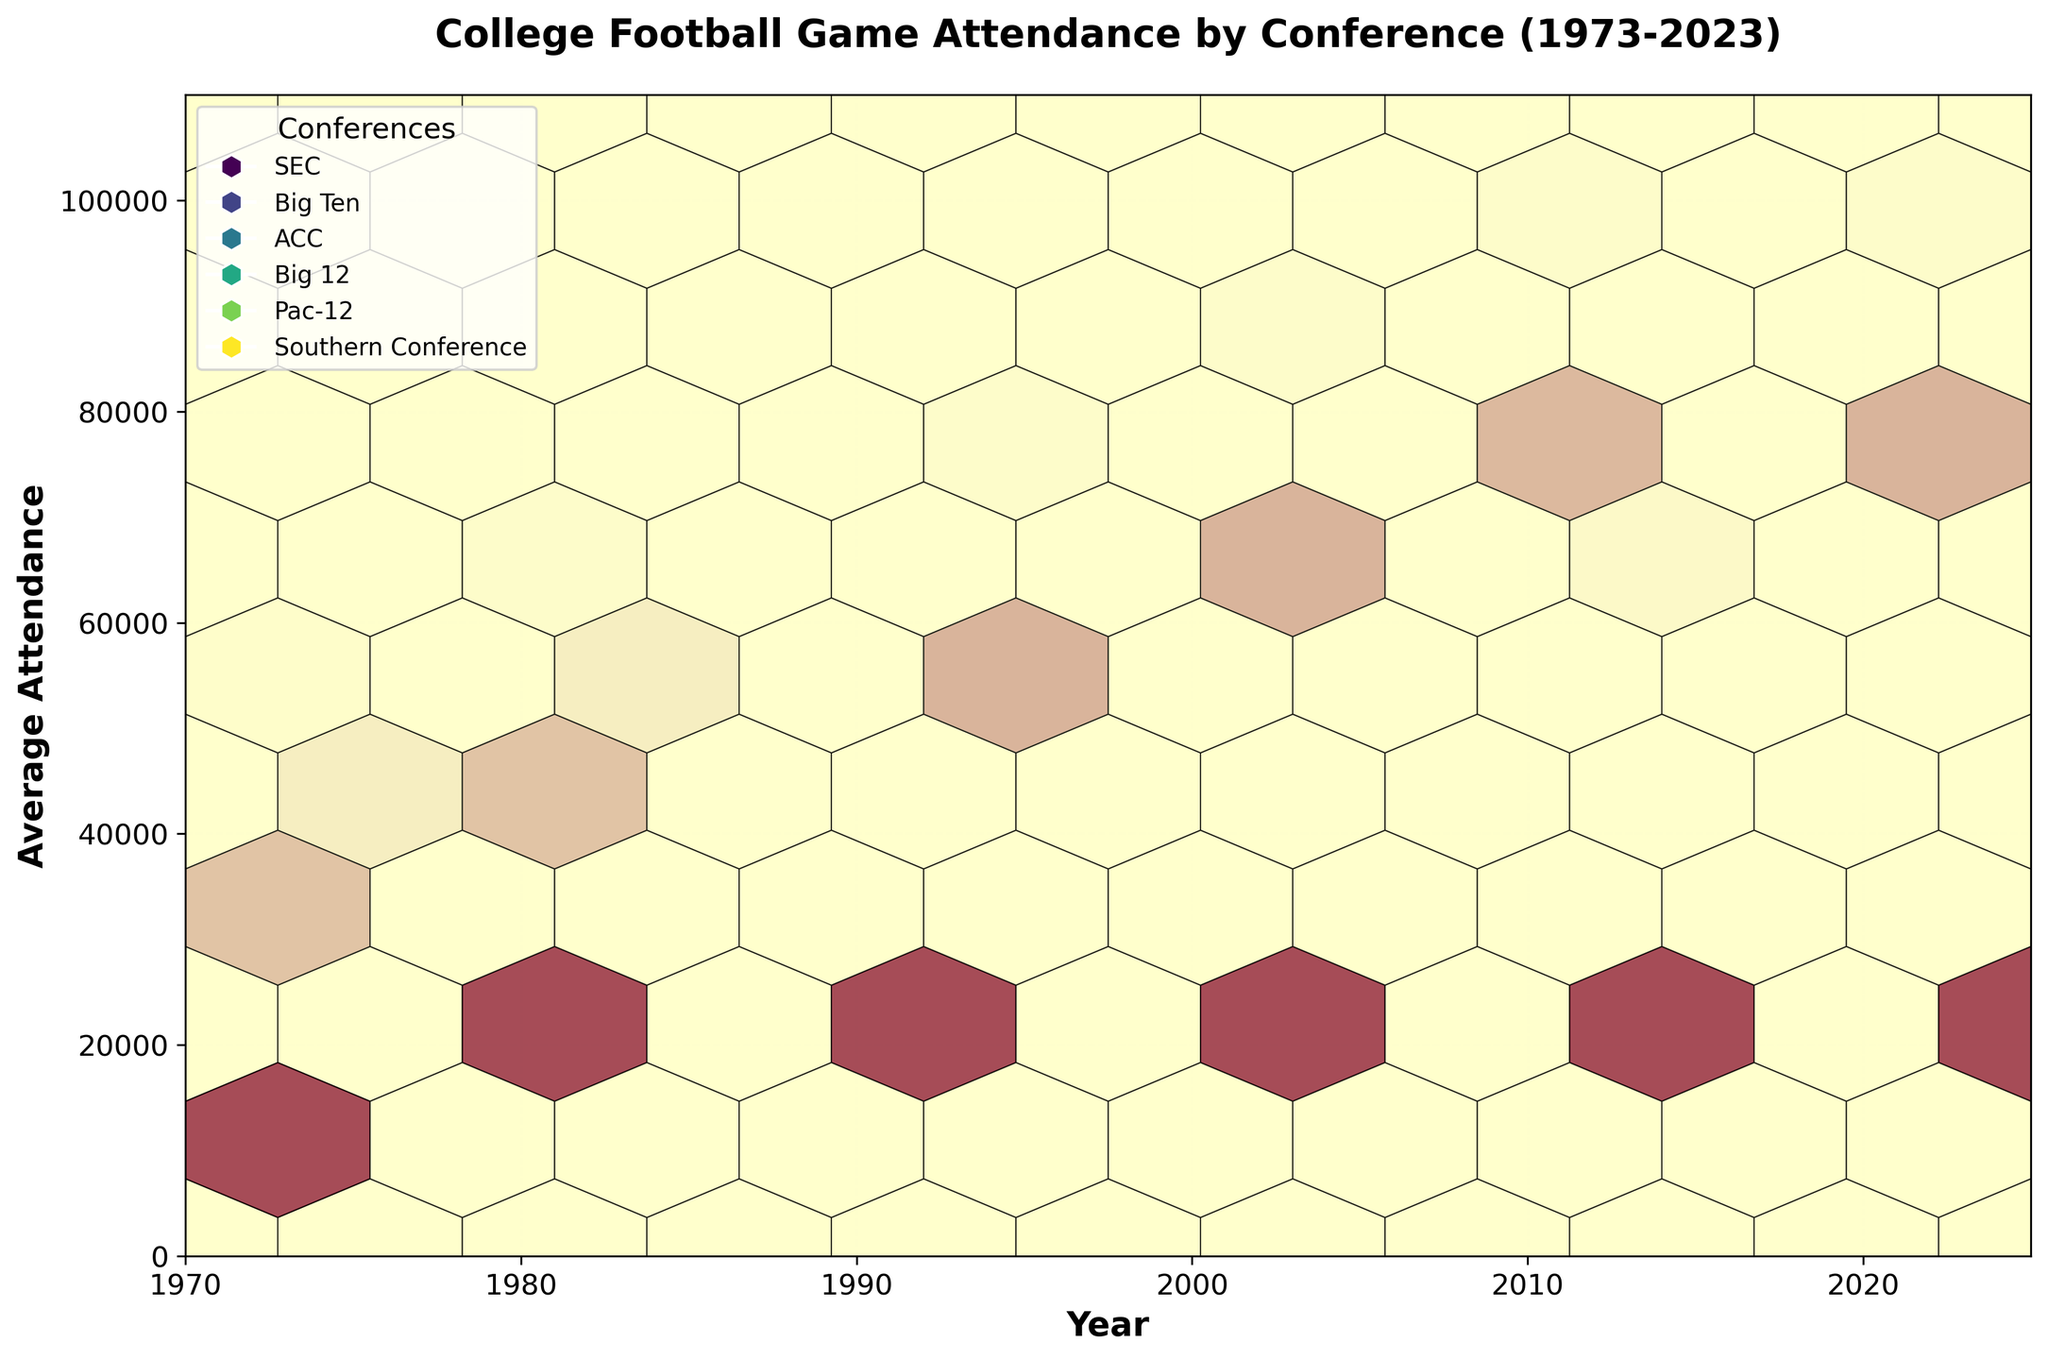what is the title of the figure? The title is displayed at the top of the figure and provides an overview of the data being presented.
Answer: College Football Game Attendance by Conference (1973-2023) What is the year range represented in the figure? The x-axis is labeled with years and spans from the beginning to the end of the given timeline.
Answer: 1970 to 2025 How are the different conferences visually differentiated in the plot? Each conference is represented with a different color, indicated by the legend on the figure.
Answer: By different colors Which conference recorded the highest average attendance in 2023? By looking at the end of the x-axis around 2023 and identifying the highest point, we see that the SEC conference has the highest average attendance.
Answer: SEC What trend can be observed for average attendance in the Southern Conference from 1973 to 2023? Trace the hexbin data points for the Southern Conference from left to right and observe the progression in values on the y-axis.
Answer: Increasing trend How does the average attendance for the Big Ten Conference in 1973 compare to that in 2023? Identify the data points for the Big Ten in 1973 and 2023, reading the values off the y-axis. Subtract the earlier value from the latter.
Answer: 50000 to 97000, an increase of 47000 Which conference showed the most steady growth in attendance over the years? By observing the slope and consistency of the data points for each conference, the conference with the most uniform increase over time can be identified.
Answer: ACC What is the average increase in attendance for the Pac-12 from 1983 to 2003? Identify the values for 1983 and 2003 for the Pac-12. Calculate the increase over the years and then divide by the number of years.
Answer: (68000 - 48000) / 20 = 1000 per year Does the SEC or Big Ten have a higher average attendance overall in the 21st century? Compare the hexbin density and average positions of the data points for the SEC and Big Ten from 2000 onwards.
Answer: SEC What can be inferred about the relationship between the Year and Average Attendance for the Big 12? Observe the distribution and general direction of the hexbin data points associated with the Big 12 over time.
Answer: Generally increasing 